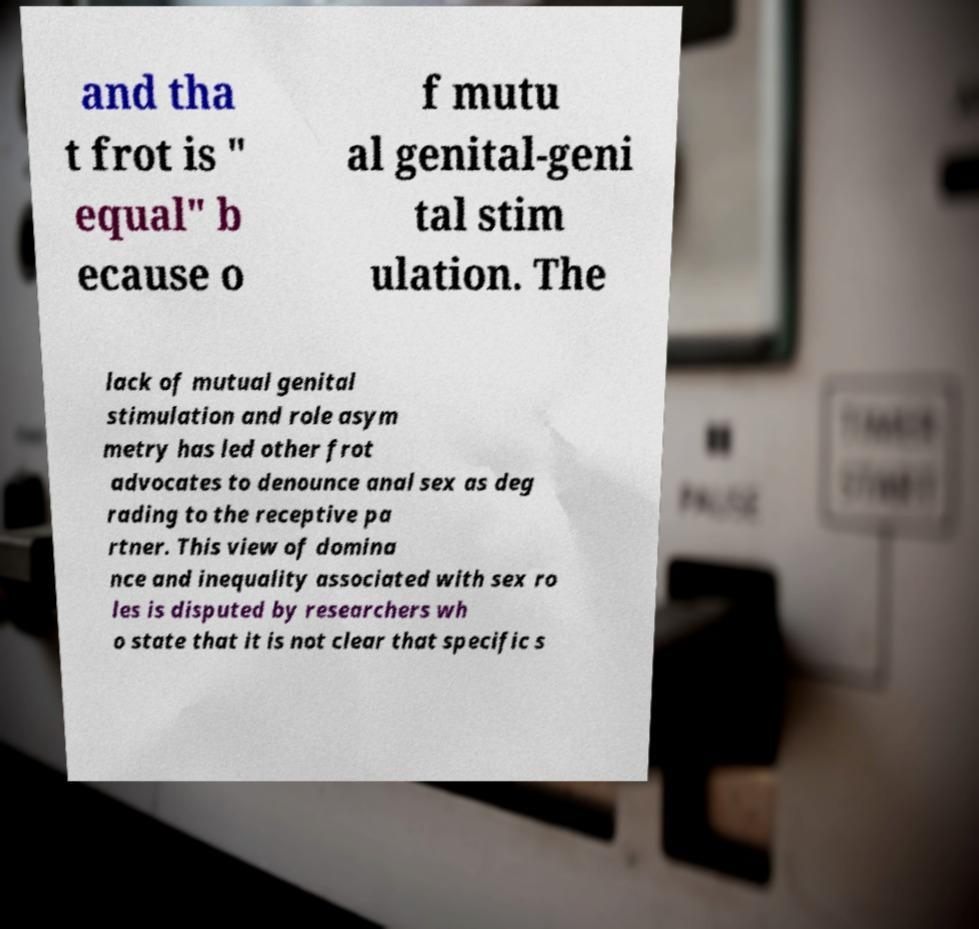What messages or text are displayed in this image? I need them in a readable, typed format. and tha t frot is " equal" b ecause o f mutu al genital-geni tal stim ulation. The lack of mutual genital stimulation and role asym metry has led other frot advocates to denounce anal sex as deg rading to the receptive pa rtner. This view of domina nce and inequality associated with sex ro les is disputed by researchers wh o state that it is not clear that specific s 